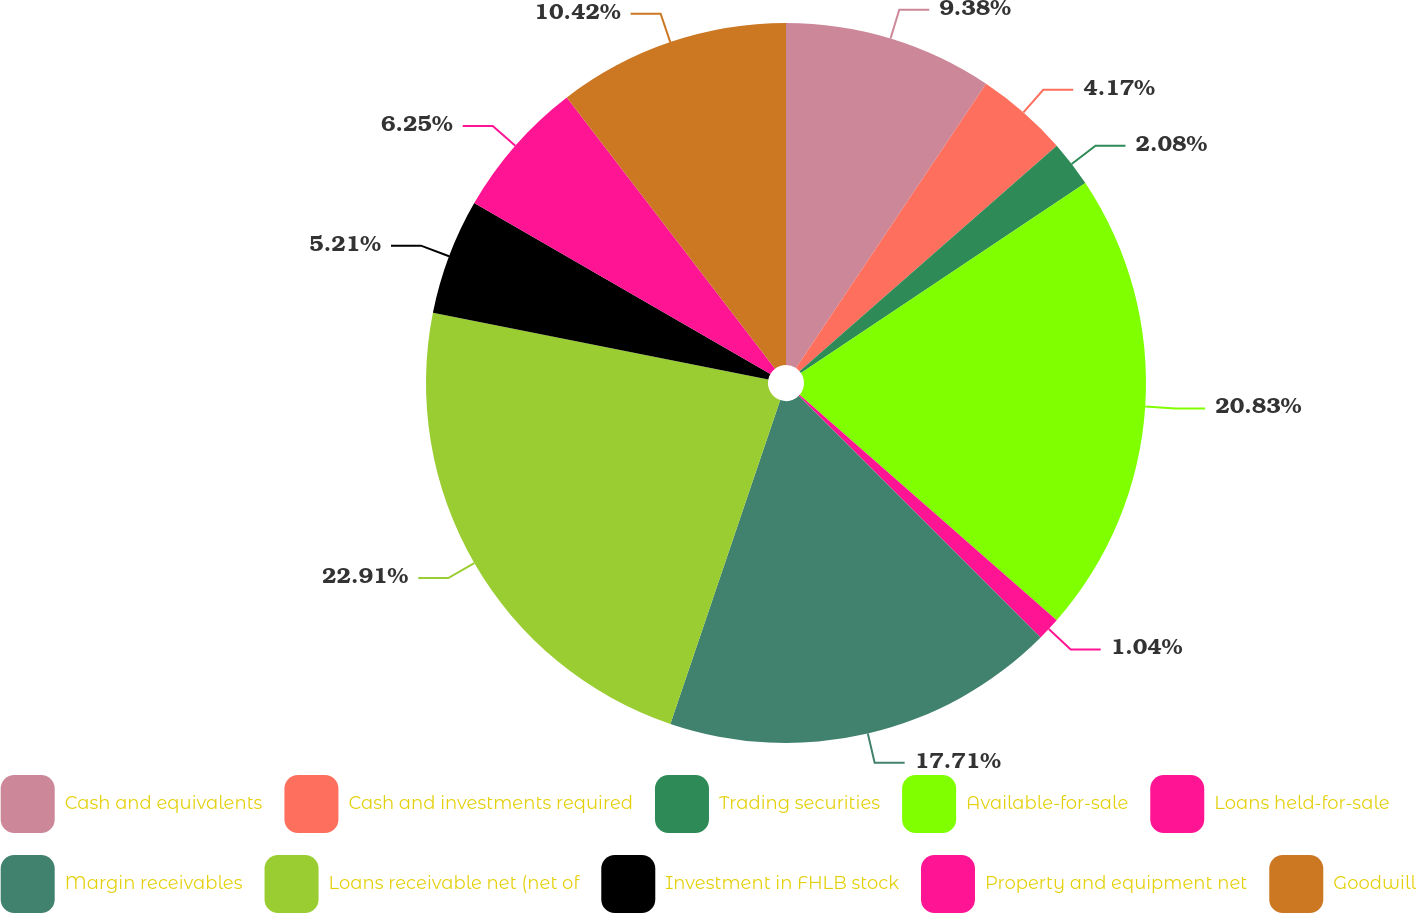Convert chart to OTSL. <chart><loc_0><loc_0><loc_500><loc_500><pie_chart><fcel>Cash and equivalents<fcel>Cash and investments required<fcel>Trading securities<fcel>Available-for-sale<fcel>Loans held-for-sale<fcel>Margin receivables<fcel>Loans receivable net (net of<fcel>Investment in FHLB stock<fcel>Property and equipment net<fcel>Goodwill<nl><fcel>9.38%<fcel>4.17%<fcel>2.08%<fcel>20.83%<fcel>1.04%<fcel>17.71%<fcel>22.92%<fcel>5.21%<fcel>6.25%<fcel>10.42%<nl></chart> 